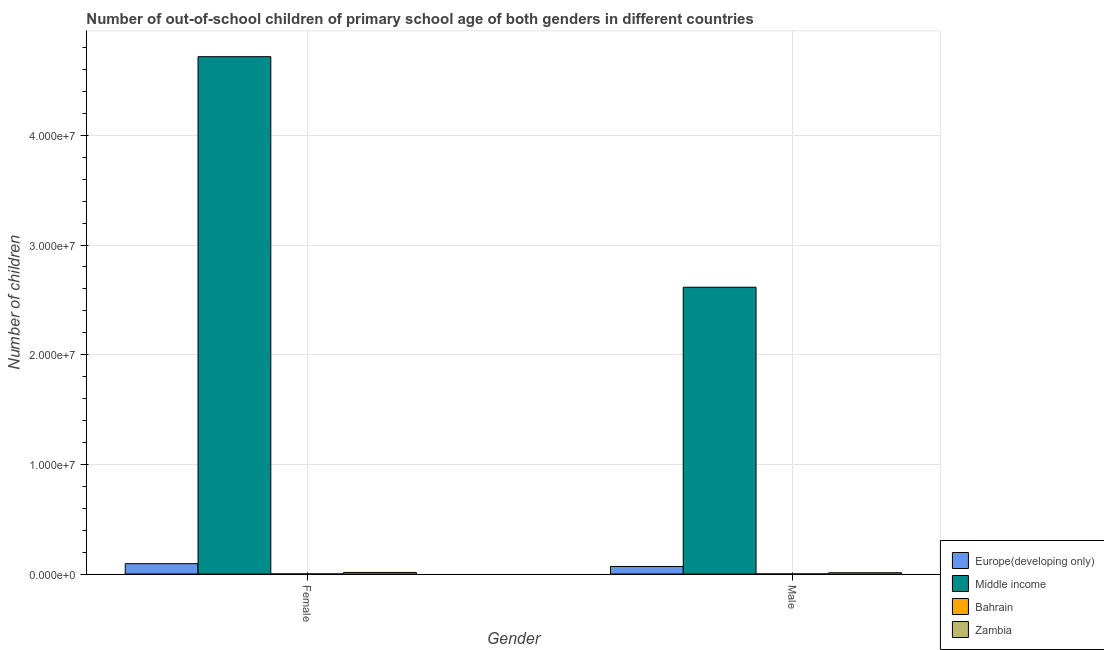How many groups of bars are there?
Ensure brevity in your answer.  2. Are the number of bars per tick equal to the number of legend labels?
Ensure brevity in your answer.  Yes. Are the number of bars on each tick of the X-axis equal?
Give a very brief answer. Yes. What is the label of the 2nd group of bars from the left?
Your answer should be compact. Male. What is the number of male out-of-school students in Bahrain?
Offer a very short reply. 370. Across all countries, what is the maximum number of female out-of-school students?
Your answer should be compact. 4.72e+07. Across all countries, what is the minimum number of male out-of-school students?
Your answer should be compact. 370. In which country was the number of female out-of-school students maximum?
Provide a succinct answer. Middle income. In which country was the number of male out-of-school students minimum?
Offer a very short reply. Bahrain. What is the total number of female out-of-school students in the graph?
Make the answer very short. 4.83e+07. What is the difference between the number of male out-of-school students in Middle income and that in Europe(developing only)?
Ensure brevity in your answer.  2.55e+07. What is the difference between the number of male out-of-school students in Europe(developing only) and the number of female out-of-school students in Zambia?
Your response must be concise. 5.44e+05. What is the average number of male out-of-school students per country?
Offer a very short reply. 6.74e+06. What is the difference between the number of female out-of-school students and number of male out-of-school students in Europe(developing only)?
Your answer should be compact. 2.54e+05. In how many countries, is the number of female out-of-school students greater than 36000000 ?
Your answer should be compact. 1. What is the ratio of the number of female out-of-school students in Zambia to that in Middle income?
Offer a very short reply. 0. Is the number of male out-of-school students in Zambia less than that in Europe(developing only)?
Give a very brief answer. Yes. What does the 1st bar from the left in Female represents?
Provide a succinct answer. Europe(developing only). What does the 1st bar from the right in Male represents?
Give a very brief answer. Zambia. How many countries are there in the graph?
Make the answer very short. 4. What is the difference between two consecutive major ticks on the Y-axis?
Keep it short and to the point. 1.00e+07. Are the values on the major ticks of Y-axis written in scientific E-notation?
Make the answer very short. Yes. Where does the legend appear in the graph?
Your response must be concise. Bottom right. How many legend labels are there?
Make the answer very short. 4. What is the title of the graph?
Your answer should be compact. Number of out-of-school children of primary school age of both genders in different countries. What is the label or title of the Y-axis?
Your answer should be very brief. Number of children. What is the Number of children in Europe(developing only) in Female?
Give a very brief answer. 9.41e+05. What is the Number of children of Middle income in Female?
Make the answer very short. 4.72e+07. What is the Number of children in Bahrain in Female?
Offer a terse response. 556. What is the Number of children in Zambia in Female?
Your answer should be compact. 1.43e+05. What is the Number of children of Europe(developing only) in Male?
Offer a terse response. 6.87e+05. What is the Number of children of Middle income in Male?
Ensure brevity in your answer.  2.61e+07. What is the Number of children in Bahrain in Male?
Keep it short and to the point. 370. What is the Number of children in Zambia in Male?
Offer a terse response. 1.14e+05. Across all Gender, what is the maximum Number of children of Europe(developing only)?
Your answer should be compact. 9.41e+05. Across all Gender, what is the maximum Number of children in Middle income?
Provide a short and direct response. 4.72e+07. Across all Gender, what is the maximum Number of children of Bahrain?
Ensure brevity in your answer.  556. Across all Gender, what is the maximum Number of children of Zambia?
Your answer should be compact. 1.43e+05. Across all Gender, what is the minimum Number of children in Europe(developing only)?
Your response must be concise. 6.87e+05. Across all Gender, what is the minimum Number of children in Middle income?
Make the answer very short. 2.61e+07. Across all Gender, what is the minimum Number of children of Bahrain?
Provide a succinct answer. 370. Across all Gender, what is the minimum Number of children of Zambia?
Give a very brief answer. 1.14e+05. What is the total Number of children in Europe(developing only) in the graph?
Your answer should be compact. 1.63e+06. What is the total Number of children of Middle income in the graph?
Your answer should be compact. 7.33e+07. What is the total Number of children of Bahrain in the graph?
Provide a succinct answer. 926. What is the total Number of children in Zambia in the graph?
Keep it short and to the point. 2.57e+05. What is the difference between the Number of children of Europe(developing only) in Female and that in Male?
Your response must be concise. 2.54e+05. What is the difference between the Number of children of Middle income in Female and that in Male?
Your response must be concise. 2.10e+07. What is the difference between the Number of children of Bahrain in Female and that in Male?
Provide a short and direct response. 186. What is the difference between the Number of children in Zambia in Female and that in Male?
Make the answer very short. 2.83e+04. What is the difference between the Number of children of Europe(developing only) in Female and the Number of children of Middle income in Male?
Offer a terse response. -2.52e+07. What is the difference between the Number of children of Europe(developing only) in Female and the Number of children of Bahrain in Male?
Offer a terse response. 9.40e+05. What is the difference between the Number of children of Europe(developing only) in Female and the Number of children of Zambia in Male?
Provide a succinct answer. 8.26e+05. What is the difference between the Number of children of Middle income in Female and the Number of children of Bahrain in Male?
Ensure brevity in your answer.  4.72e+07. What is the difference between the Number of children in Middle income in Female and the Number of children in Zambia in Male?
Ensure brevity in your answer.  4.71e+07. What is the difference between the Number of children of Bahrain in Female and the Number of children of Zambia in Male?
Your answer should be very brief. -1.14e+05. What is the average Number of children in Europe(developing only) per Gender?
Provide a short and direct response. 8.14e+05. What is the average Number of children of Middle income per Gender?
Make the answer very short. 3.67e+07. What is the average Number of children in Bahrain per Gender?
Offer a terse response. 463. What is the average Number of children in Zambia per Gender?
Make the answer very short. 1.29e+05. What is the difference between the Number of children in Europe(developing only) and Number of children in Middle income in Female?
Make the answer very short. -4.62e+07. What is the difference between the Number of children in Europe(developing only) and Number of children in Bahrain in Female?
Provide a succinct answer. 9.40e+05. What is the difference between the Number of children of Europe(developing only) and Number of children of Zambia in Female?
Make the answer very short. 7.98e+05. What is the difference between the Number of children of Middle income and Number of children of Bahrain in Female?
Make the answer very short. 4.72e+07. What is the difference between the Number of children of Middle income and Number of children of Zambia in Female?
Provide a succinct answer. 4.70e+07. What is the difference between the Number of children of Bahrain and Number of children of Zambia in Female?
Your answer should be compact. -1.42e+05. What is the difference between the Number of children of Europe(developing only) and Number of children of Middle income in Male?
Ensure brevity in your answer.  -2.55e+07. What is the difference between the Number of children in Europe(developing only) and Number of children in Bahrain in Male?
Make the answer very short. 6.86e+05. What is the difference between the Number of children of Europe(developing only) and Number of children of Zambia in Male?
Offer a terse response. 5.72e+05. What is the difference between the Number of children of Middle income and Number of children of Bahrain in Male?
Your response must be concise. 2.61e+07. What is the difference between the Number of children of Middle income and Number of children of Zambia in Male?
Keep it short and to the point. 2.60e+07. What is the difference between the Number of children in Bahrain and Number of children in Zambia in Male?
Provide a succinct answer. -1.14e+05. What is the ratio of the Number of children of Europe(developing only) in Female to that in Male?
Ensure brevity in your answer.  1.37. What is the ratio of the Number of children in Middle income in Female to that in Male?
Provide a succinct answer. 1.8. What is the ratio of the Number of children in Bahrain in Female to that in Male?
Your answer should be compact. 1.5. What is the ratio of the Number of children of Zambia in Female to that in Male?
Offer a terse response. 1.25. What is the difference between the highest and the second highest Number of children of Europe(developing only)?
Give a very brief answer. 2.54e+05. What is the difference between the highest and the second highest Number of children in Middle income?
Ensure brevity in your answer.  2.10e+07. What is the difference between the highest and the second highest Number of children of Bahrain?
Offer a terse response. 186. What is the difference between the highest and the second highest Number of children in Zambia?
Your answer should be very brief. 2.83e+04. What is the difference between the highest and the lowest Number of children of Europe(developing only)?
Offer a very short reply. 2.54e+05. What is the difference between the highest and the lowest Number of children in Middle income?
Provide a succinct answer. 2.10e+07. What is the difference between the highest and the lowest Number of children of Bahrain?
Make the answer very short. 186. What is the difference between the highest and the lowest Number of children of Zambia?
Keep it short and to the point. 2.83e+04. 